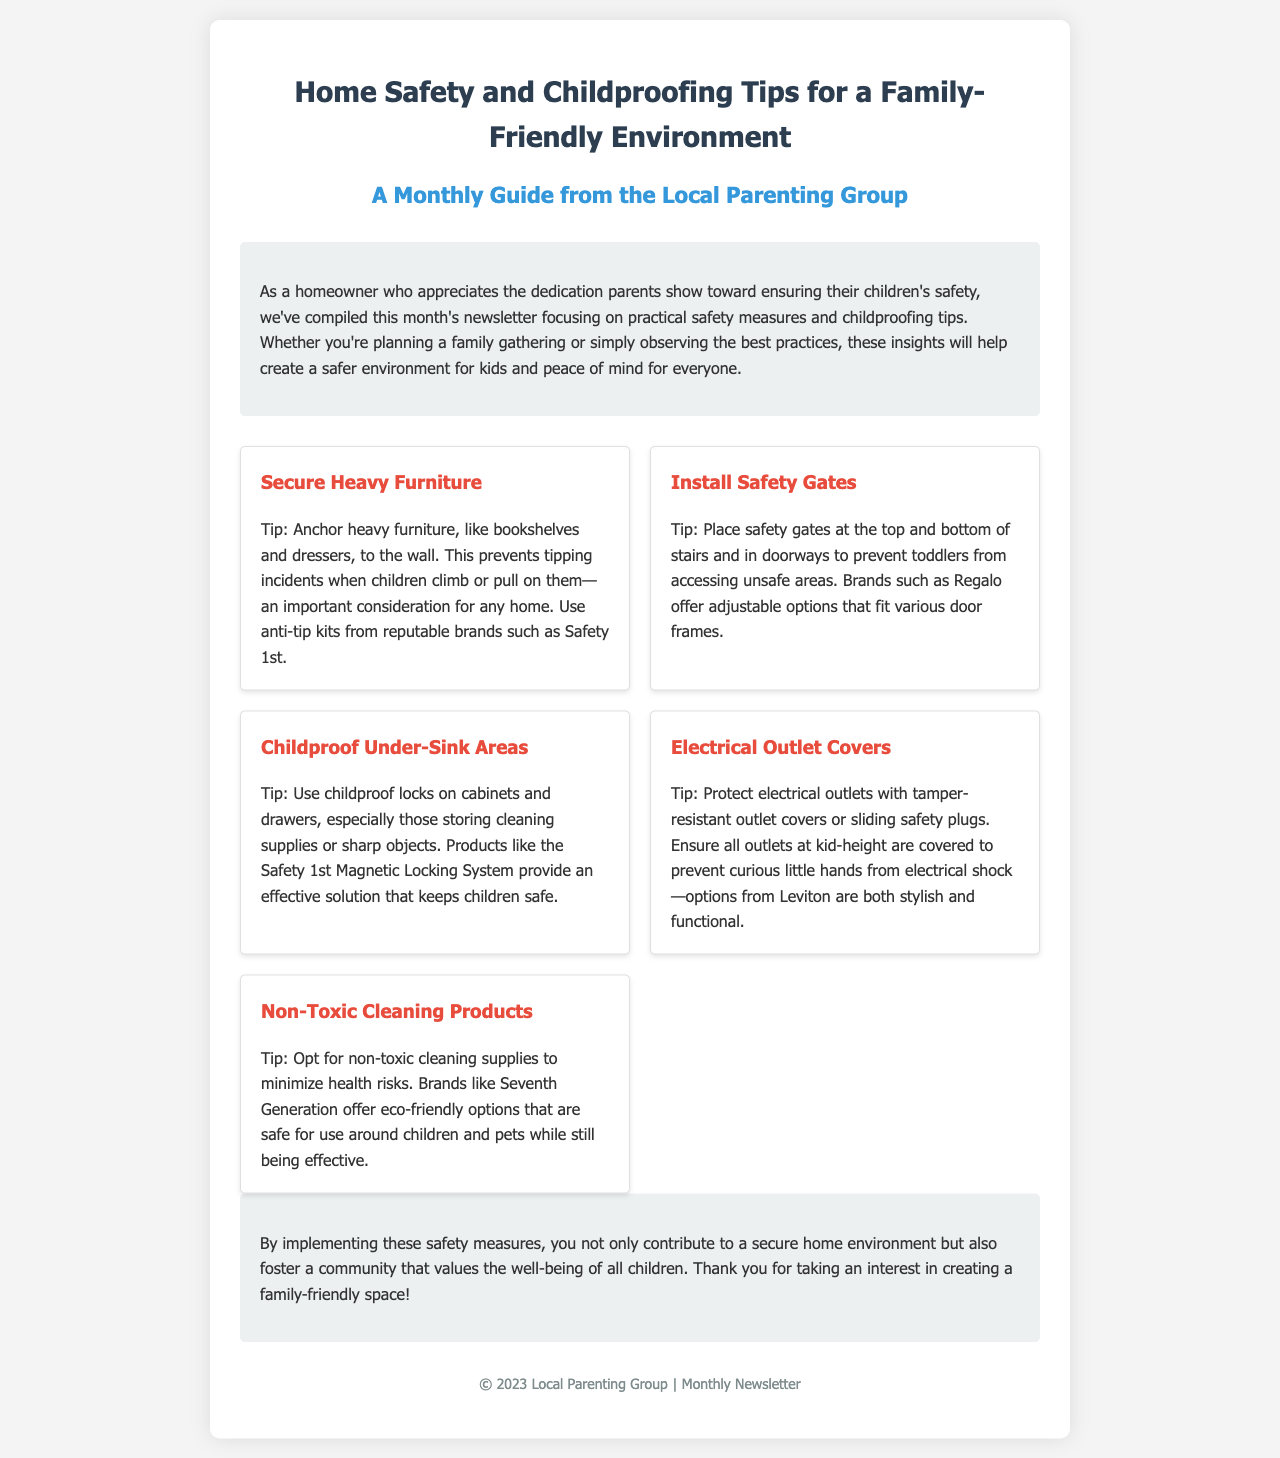What is the title of the newsletter? The title presented in the header section of the document is "Home Safety and Childproofing Tips for a Family-Friendly Environment."
Answer: Home Safety and Childproofing Tips for a Family-Friendly Environment Who is the newsletter from? The footer indicates that the newsletter is from the "Local Parenting Group."
Answer: Local Parenting Group How many safety tips are listed in the document? The document includes a total of five safety tips for home safety and childproofing.
Answer: 5 What product is recommended for securing heavy furniture? The document mentions "anti-tip kits" from reputable brands like "Safety 1st" for securing heavy furniture.
Answer: Safety 1st What is a suggested brand for non-toxic cleaning supplies? The newsletter recommends "Seventh Generation" as a brand for non-toxic cleaning supplies.
Answer: Seventh Generation Why is it important to use childproof locks? The document emphasizes childproof locks on cabinets and drawers to prevent access to dangerous items such as cleaning supplies.
Answer: Access to dangerous items What is one way to protect electrical outlets? The document suggests using "tamper-resistant outlet covers" or "sliding safety plugs" to protect electrical outlets.
Answer: Tamper-resistant outlet covers Where should safety gates be placed? According to the document, safety gates should be placed at the "top and bottom of stairs and in doorways."
Answer: Top and bottom of stairs and in doorways What is the purpose of the monthly newsletter? The purpose of the newsletter is to share tips on "home safety measures and childproofing" for a family-friendly environment.
Answer: Share tips on home safety measures and childproofing 